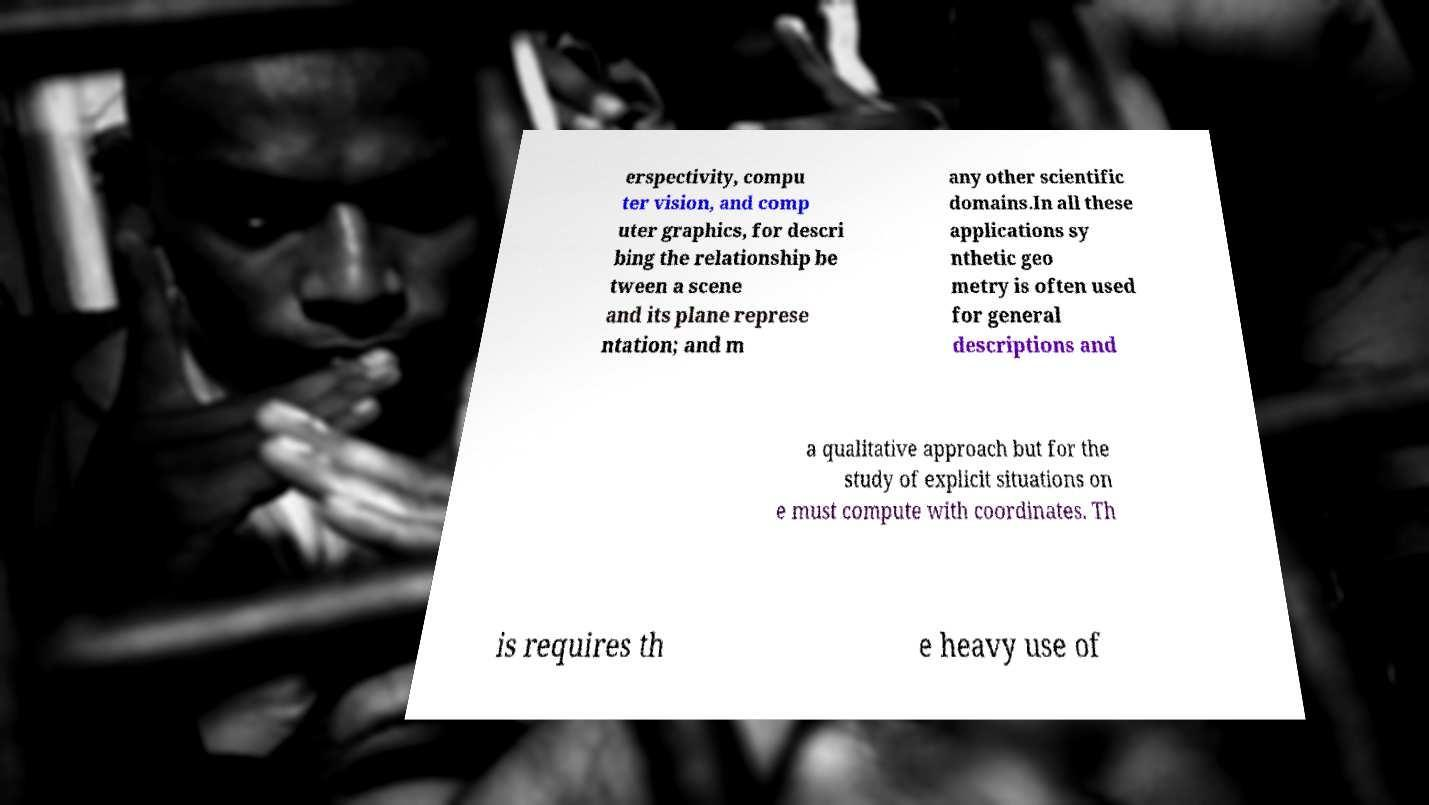Please read and relay the text visible in this image. What does it say? erspectivity, compu ter vision, and comp uter graphics, for descri bing the relationship be tween a scene and its plane represe ntation; and m any other scientific domains.In all these applications sy nthetic geo metry is often used for general descriptions and a qualitative approach but for the study of explicit situations on e must compute with coordinates. Th is requires th e heavy use of 